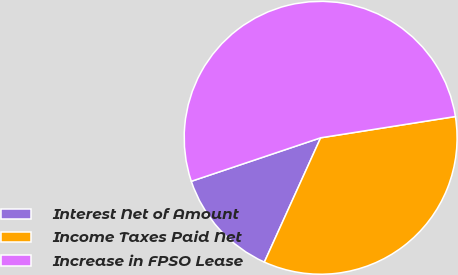Convert chart. <chart><loc_0><loc_0><loc_500><loc_500><pie_chart><fcel>Interest Net of Amount<fcel>Income Taxes Paid Net<fcel>Increase in FPSO Lease<nl><fcel>13.07%<fcel>34.26%<fcel>52.67%<nl></chart> 